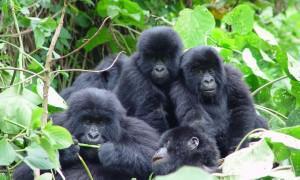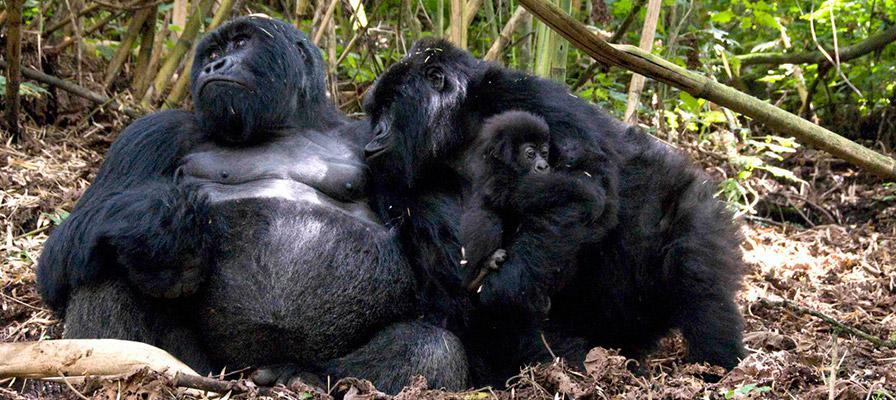The first image is the image on the left, the second image is the image on the right. Considering the images on both sides, is "There's no more than four gorillas in the right image." valid? Answer yes or no. Yes. 